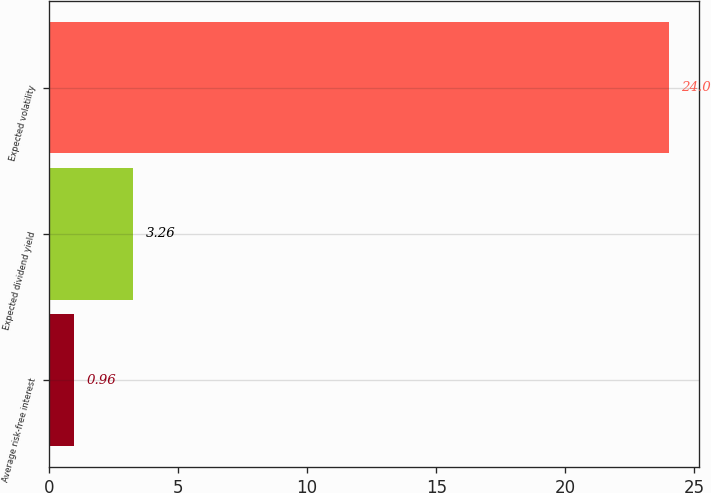Convert chart. <chart><loc_0><loc_0><loc_500><loc_500><bar_chart><fcel>Average risk-free interest<fcel>Expected dividend yield<fcel>Expected volatility<nl><fcel>0.96<fcel>3.26<fcel>24<nl></chart> 